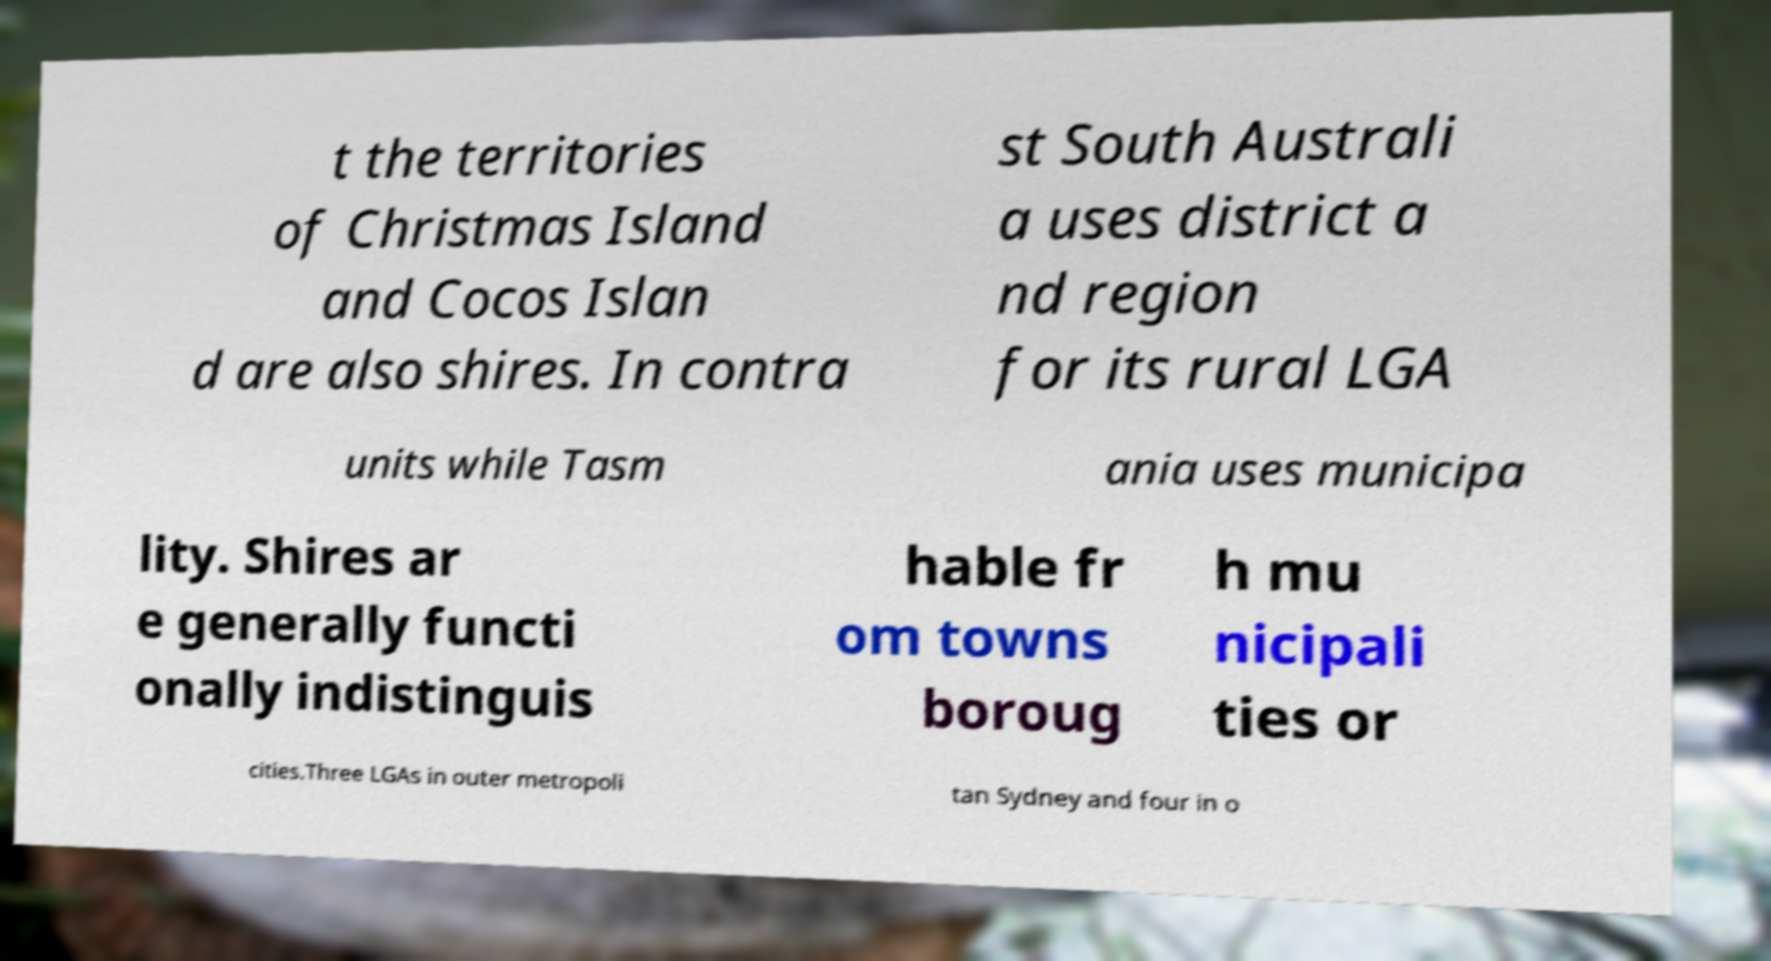Please read and relay the text visible in this image. What does it say? t the territories of Christmas Island and Cocos Islan d are also shires. In contra st South Australi a uses district a nd region for its rural LGA units while Tasm ania uses municipa lity. Shires ar e generally functi onally indistinguis hable fr om towns boroug h mu nicipali ties or cities.Three LGAs in outer metropoli tan Sydney and four in o 